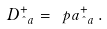<formula> <loc_0><loc_0><loc_500><loc_500>D ^ { + } _ { \hat { \ } a } = \ p a ^ { + } _ { \hat { \ } a } \, .</formula> 